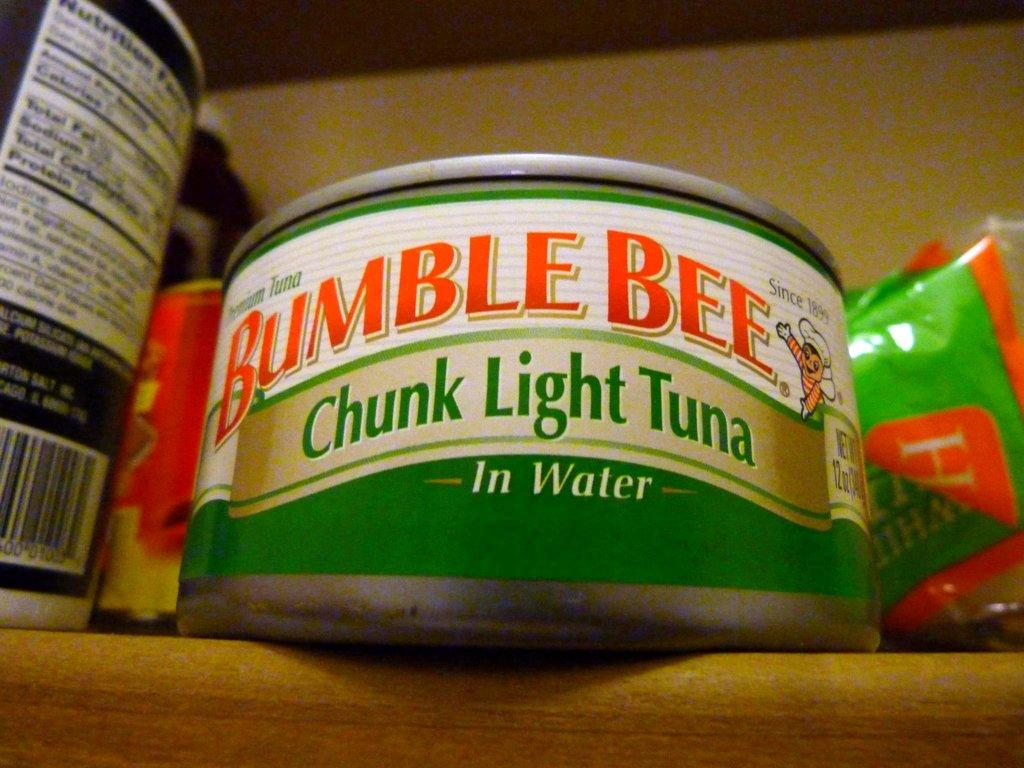<image>
Provide a brief description of the given image. A shelf with a can of Bumble Bee chunk light tuna in water next to other food products. 